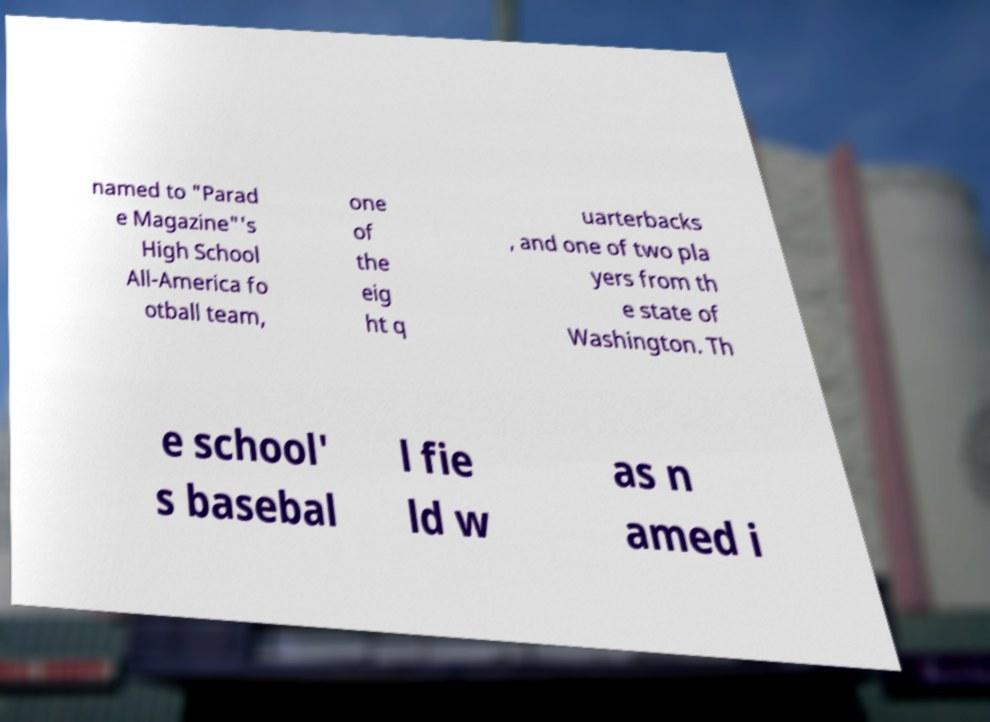What messages or text are displayed in this image? I need them in a readable, typed format. named to "Parad e Magazine"'s High School All-America fo otball team, one of the eig ht q uarterbacks , and one of two pla yers from th e state of Washington. Th e school' s basebal l fie ld w as n amed i 